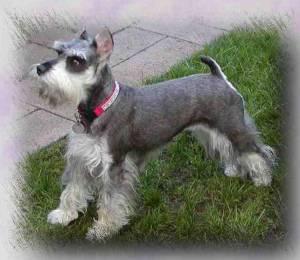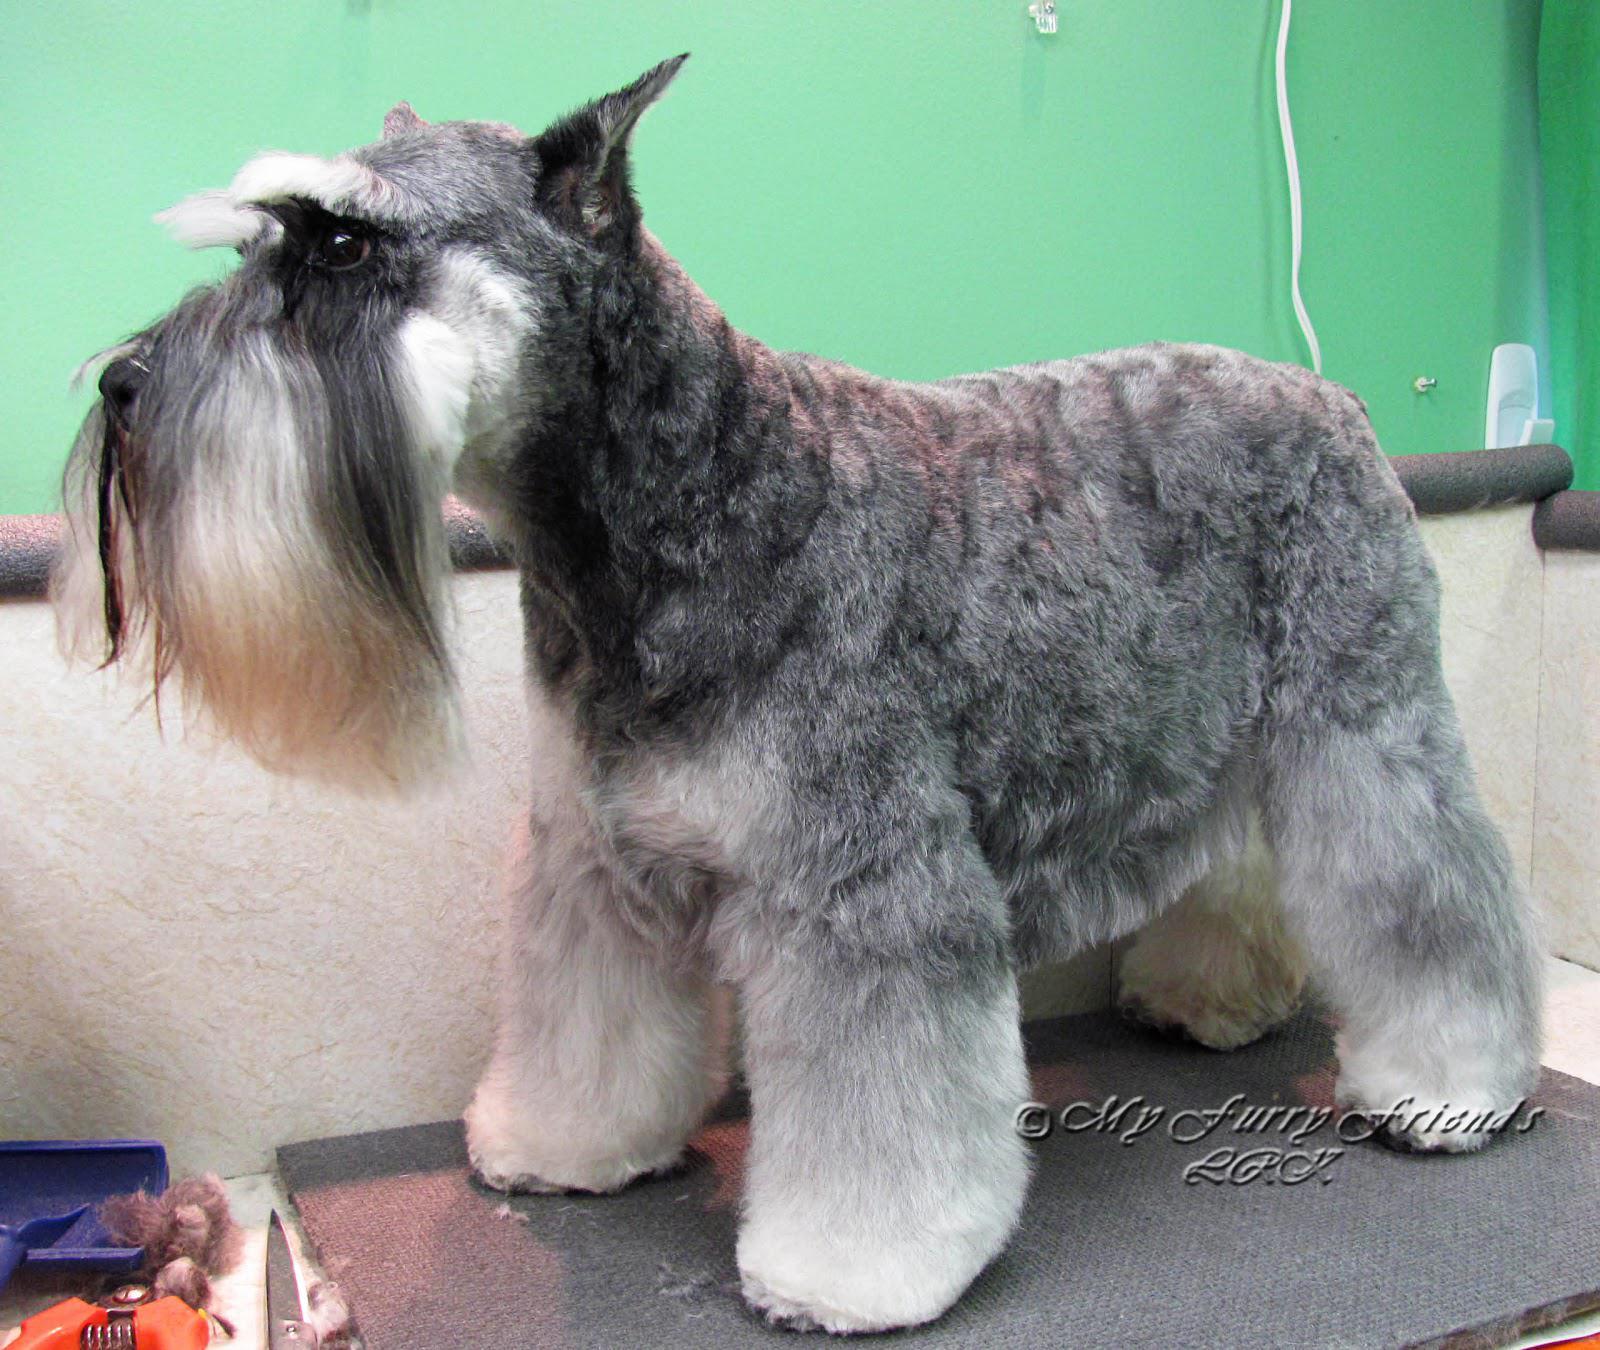The first image is the image on the left, the second image is the image on the right. Analyze the images presented: Is the assertion "the right image has a dog on a gray floor mat and green walls" valid? Answer yes or no. Yes. The first image is the image on the left, the second image is the image on the right. Considering the images on both sides, is "A dog poses in one of the images, on a table, in front of a green wall." valid? Answer yes or no. Yes. 